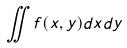<formula> <loc_0><loc_0><loc_500><loc_500>\iint f ( x , y ) d x d y</formula> 